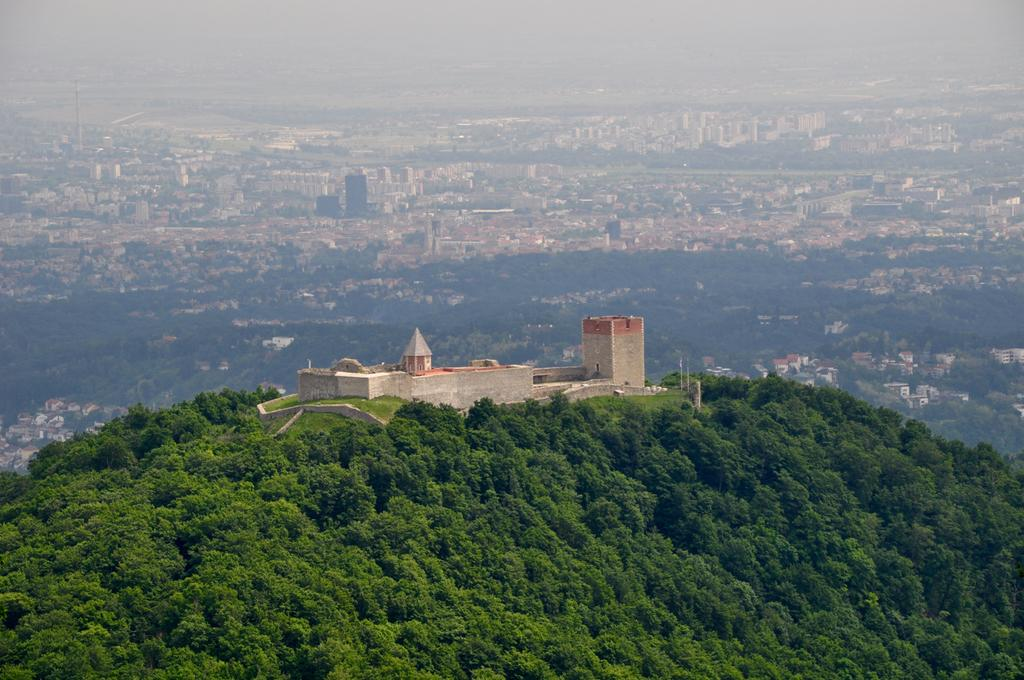What is the main structure in the image? There is a house in the middle of the image. What type of natural elements can be seen in the image? There are trees in the image. What type of vegetable is hanging from the sign in the image? There is no sign or vegetable present in the image. What type of cart can be seen in the image? There is no cart present in the image. 